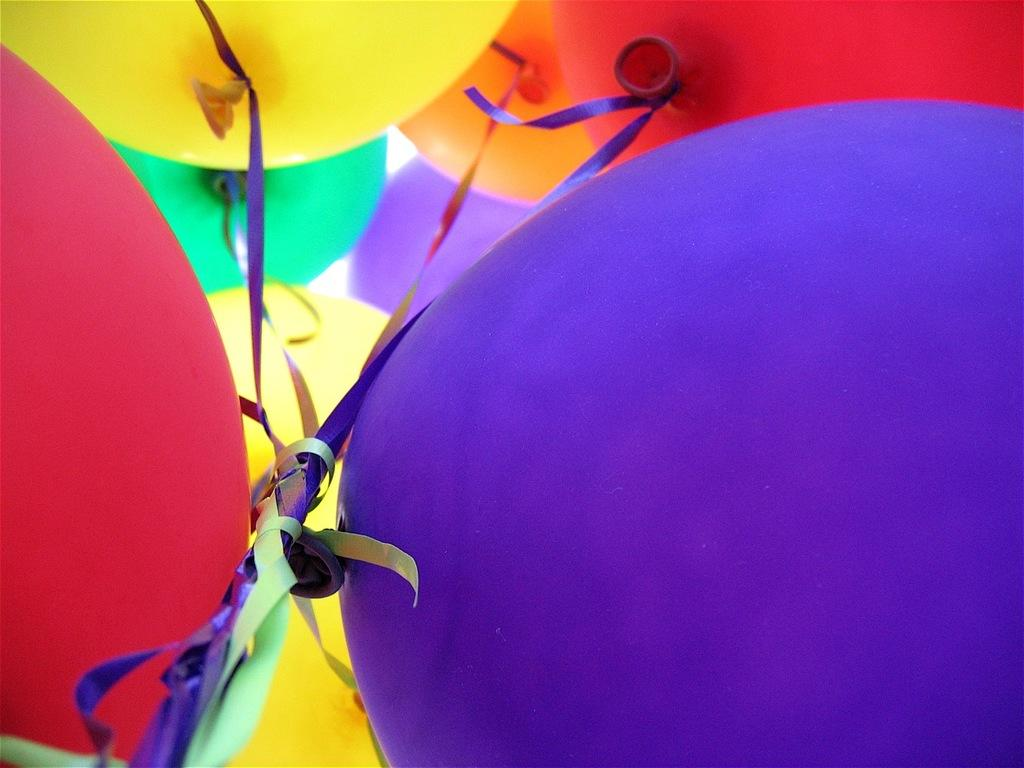What objects are present in the image? There are balloons in the image. Can you describe the balloons in the image? The balloons are of different colors: yellow, green, red, orange, and blue. What is attached to the balloons? Ribbons are tied to the balloons. How much milk does the balloon on the left hold in the image? There is no milk present in the image, as it features balloons with ribbons. 